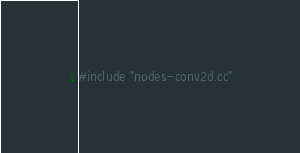<code> <loc_0><loc_0><loc_500><loc_500><_Cuda_>#include "nodes-conv2d.cc"
</code> 